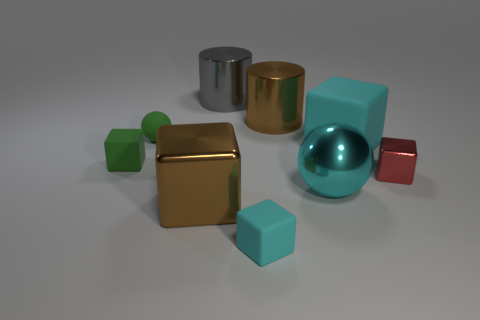Which object stands out most to you and why? The shiny teal sphere stands out most prominently due to its smooth, curved surface that contrasts with the angular shapes of the blocks and cylinder. Its reflective surface captures the light differently than the other objects, giving it a unique glow. 